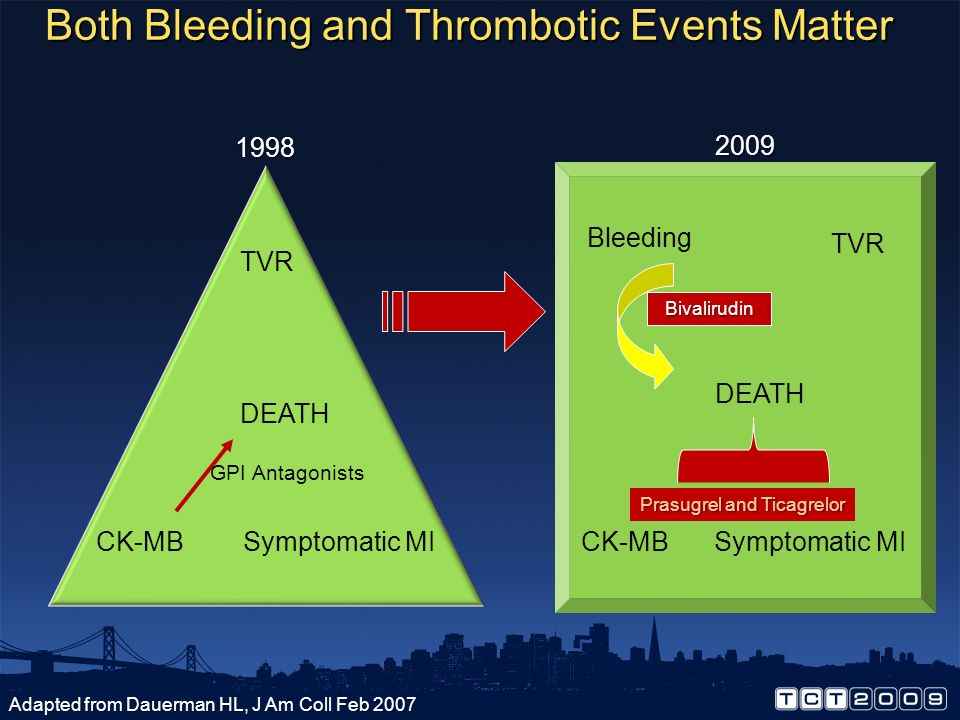What could the inclusion of the term "Bleeding" in the 2009 section imply about the evolution of considerations in medical treatment or outcomes? The inclusion of the term "Bleeding" in the 2009 section could indicate a more holistic approach in the evaluation and management of thrombotic events. By 2009, medical professionals might have recognized that while addressing thrombotic risks, it was equally important to consider the potential bleeding complications associated with treatments. The depiction of Bivalirudin, an anticoagulant, in the context of balancing bleeding and thrombosis risks, signifies a broader understanding of patient safety and outcome optimization. This evolution in focus likely represents a shift towards a more comprehensive strategy that acknowledges and mitigates side effects, aiming for an ideal balance between preventing thrombosis and minimizing bleeding risks. 